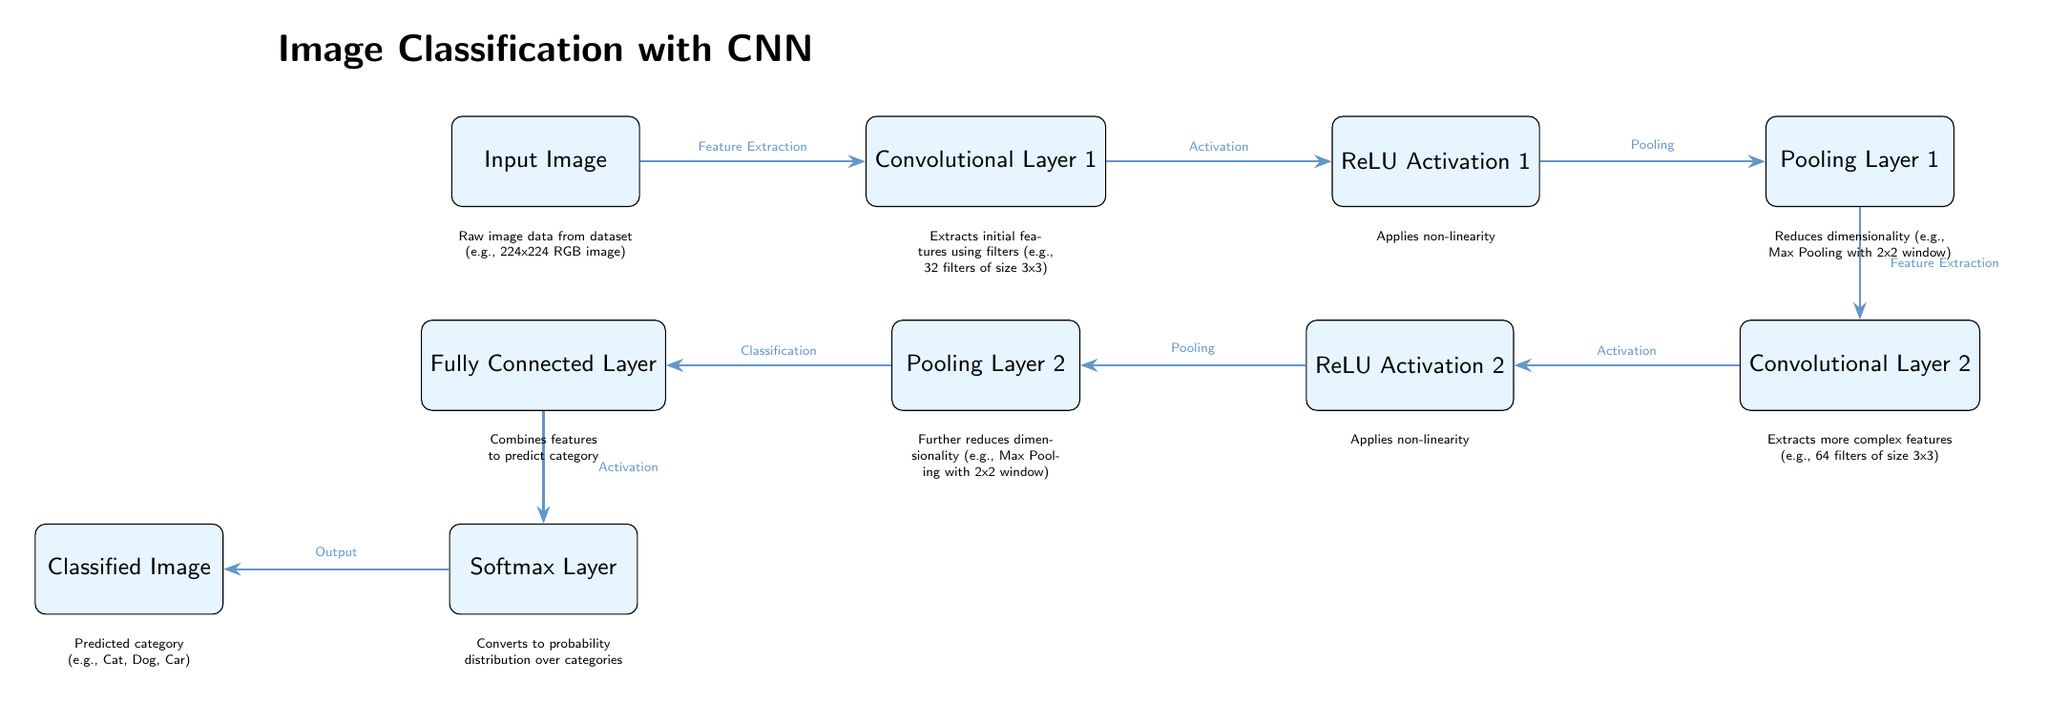What is the first layer of the CNN? The diagram shows that the first layer is labeled as "Convolutional Layer 1," which is the initial stage of the CNN workflow for image classification.
Answer: Convolutional Layer 1 How many pooling layers are in the diagram? The diagram indicates that there are two pooling layers, specifically labeled as "Pooling Layer 1" and "Pooling Layer 2."
Answer: 2 What is the function of the Softmax Layer? The diagram states that the Softmax Layer "Converts to probability distribution over categories," indicating its role in the final classification output of the CNN.
Answer: Converts to probability distribution over categories What happens between the Fully Connected Layer and the Softmax Layer? According to the diagram, the arrow between the Fully Connected Layer and the Softmax Layer is labeled "Activation," suggesting that a non-linear activation function is applied before passing to the softmax conversion.
Answer: Activation Which layer extracts more complex features? The diagram identifies "Convolutional Layer 2" as the layer responsible for extracting more complex features, as indicated in its description below the node.
Answer: Convolutional Layer 2 What type of activation function is used in the CNN? The diagram labels the activation layers as "ReLU Activation 1" and "ReLU Activation 2," indicating that the ReLU (Rectified Linear Unit) function is used in both activation stages of the CNN workflow.
Answer: ReLU What is the corresponding output of the CNN? The diagram specifies that the final output of the CNN is labeled "Classified Image," representing the image categorization as a result of the classification process.
Answer: Classified Image What is applied after Convolutional Layer 1? From the diagram, after Convolutional Layer 1, the "ReLU Activation 1" is applied next in the workflow, as shown by the directing arrow indicating the flow of data through the network.
Answer: ReLU Activation 1 What component reduces dimensionality in Layer 1? The diagram states "Pooling Layer 1" follows “ReLU Activation 1” in the flow, thus playing the role of reducing dimensionality after the first convolutional and activation step.
Answer: Pooling Layer 1 